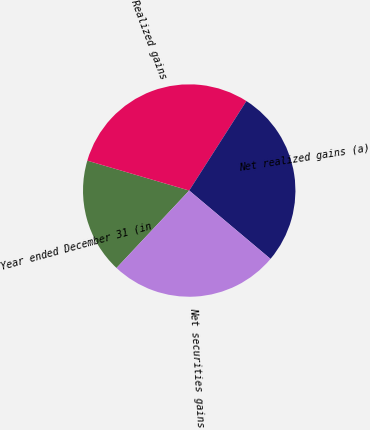Convert chart. <chart><loc_0><loc_0><loc_500><loc_500><pie_chart><fcel>Year ended December 31 (in<fcel>Realized gains<fcel>Net realized gains (a)<fcel>Net securities gains<nl><fcel>17.54%<fcel>29.51%<fcel>27.07%<fcel>25.87%<nl></chart> 